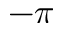<formula> <loc_0><loc_0><loc_500><loc_500>- \pi</formula> 